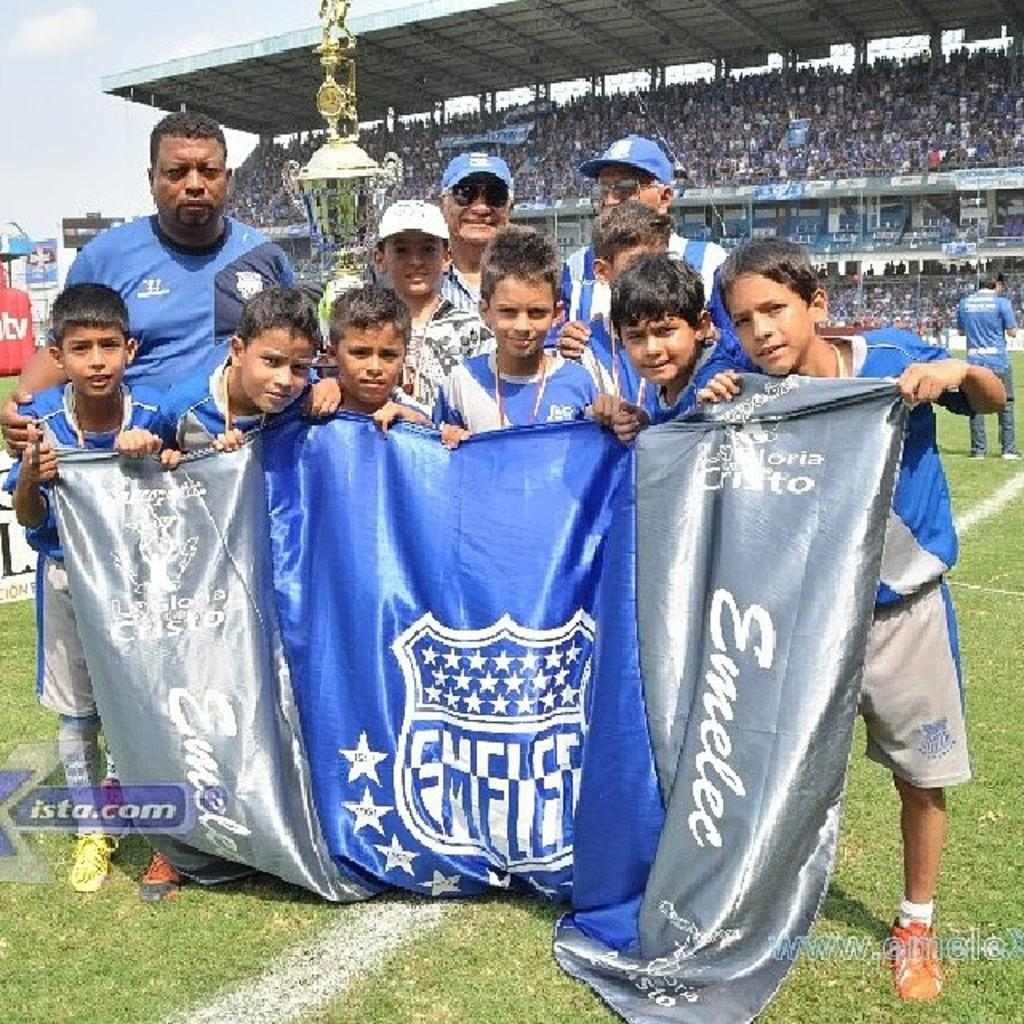<image>
Offer a succinct explanation of the picture presented. Young boys holding a blue and gray sign that says Emelee. 